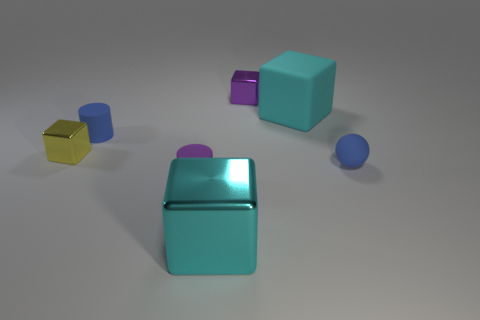How many large things are the same color as the rubber ball?
Your answer should be compact. 0. Is the number of cyan metal things behind the cyan matte thing less than the number of yellow things that are to the right of the blue cylinder?
Your answer should be compact. No. There is a small blue sphere; are there any small balls behind it?
Provide a short and direct response. No. There is a large cyan block that is right of the big cyan block in front of the small blue ball; is there a tiny purple metal block to the left of it?
Ensure brevity in your answer.  Yes. There is a blue matte object that is to the left of the rubber cube; is its shape the same as the yellow thing?
Your answer should be compact. No. There is a large thing that is the same material as the yellow cube; what is its color?
Offer a terse response. Cyan. What number of big cyan objects have the same material as the ball?
Make the answer very short. 1. The cylinder that is to the left of the tiny purple thing to the left of the big block that is in front of the yellow metallic thing is what color?
Give a very brief answer. Blue. Do the blue cylinder and the blue ball have the same size?
Provide a short and direct response. Yes. Are there any other things that are the same shape as the tiny purple matte thing?
Your answer should be compact. Yes. 